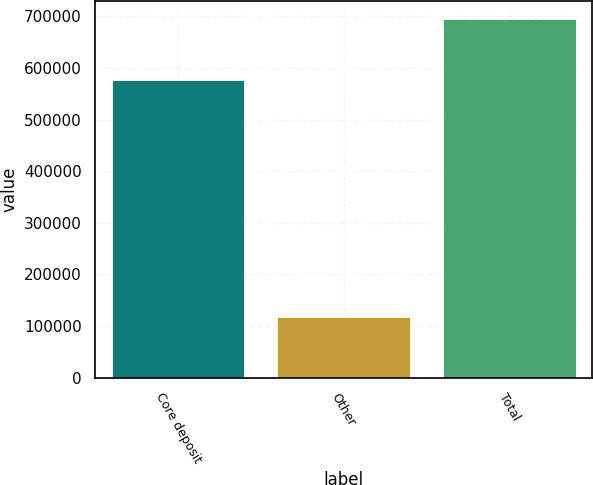<chart> <loc_0><loc_0><loc_500><loc_500><bar_chart><fcel>Core deposit<fcel>Other<fcel>Total<nl><fcel>576986<fcel>118065<fcel>695051<nl></chart> 